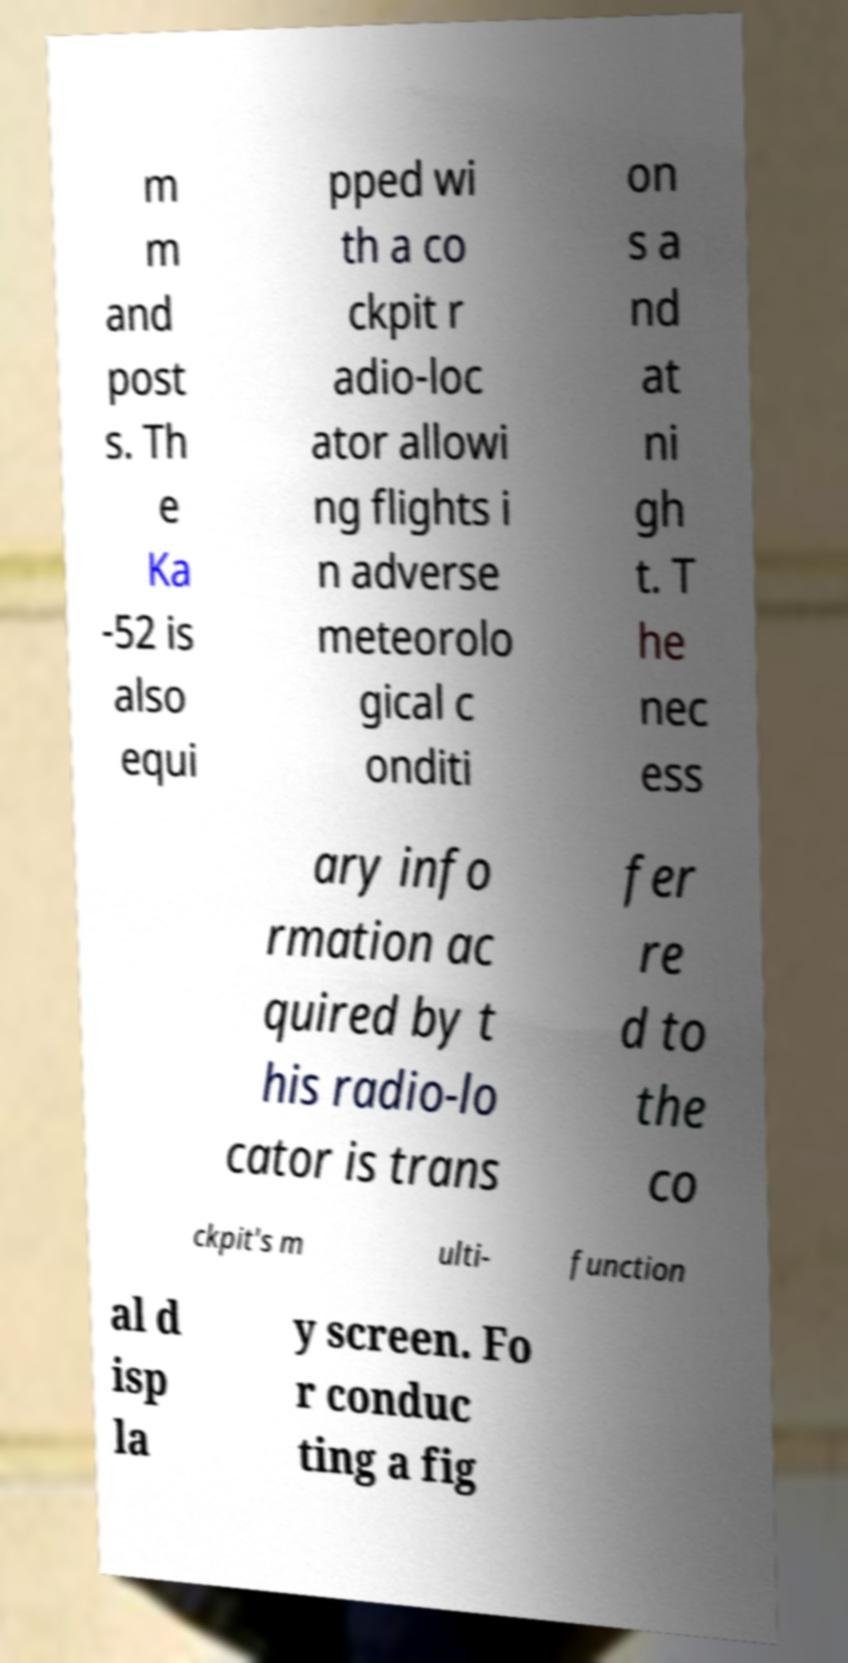What messages or text are displayed in this image? I need them in a readable, typed format. m m and post s. Th e Ka -52 is also equi pped wi th a co ckpit r adio-loc ator allowi ng flights i n adverse meteorolo gical c onditi on s a nd at ni gh t. T he nec ess ary info rmation ac quired by t his radio-lo cator is trans fer re d to the co ckpit's m ulti- function al d isp la y screen. Fo r conduc ting a fig 